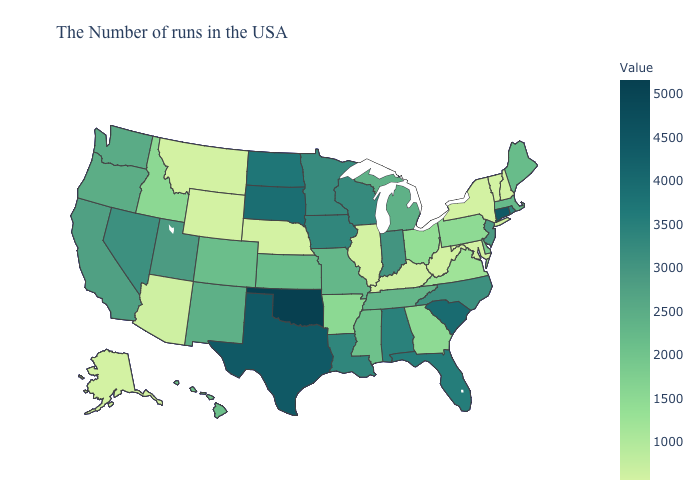Does the map have missing data?
Give a very brief answer. No. Which states hav the highest value in the West?
Concise answer only. Nevada. Does Utah have a lower value than West Virginia?
Write a very short answer. No. Does South Carolina have the highest value in the South?
Short answer required. No. Does New Hampshire have the lowest value in the Northeast?
Concise answer only. Yes. 